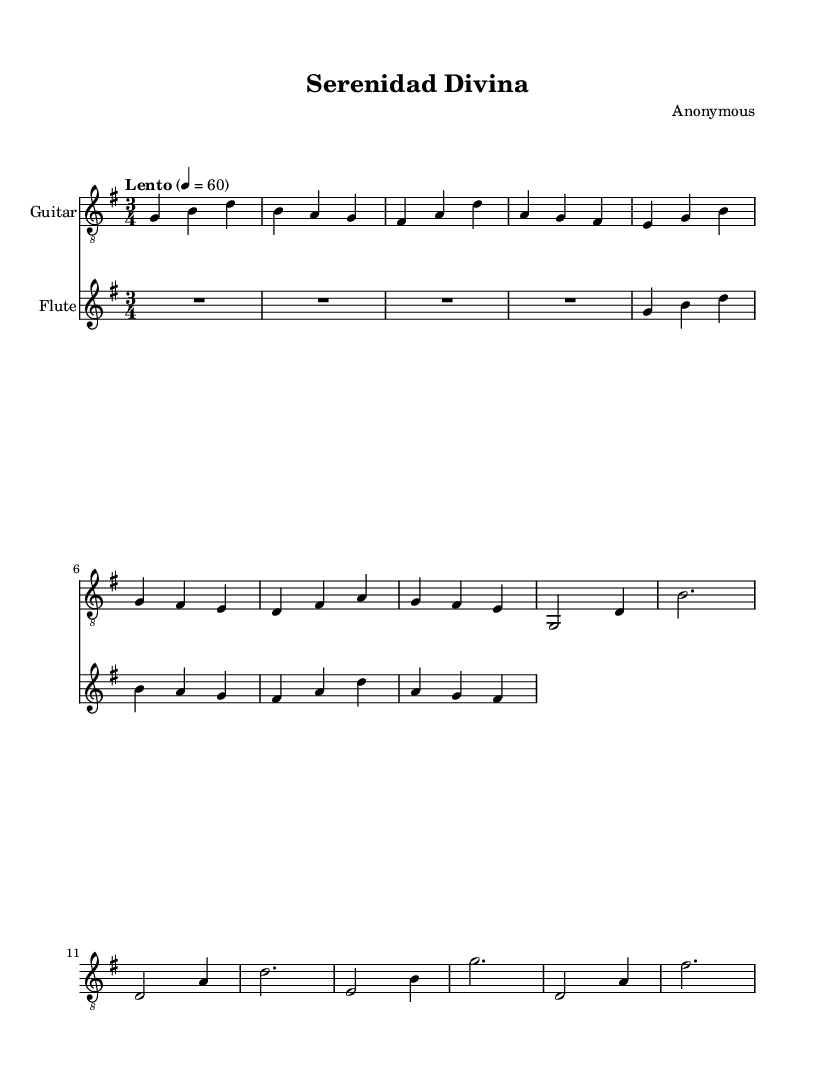What is the key signature of this music? The key signature appears at the beginning of the staff; it shows one sharp, indicating it's in G major.
Answer: G major What is the time signature of this music? The time signature is found at the beginning of the sheet music and is indicated as 3/4, meaning there are three beats per measure, and a quarter note receives one beat.
Answer: 3/4 What is the tempo marking of this piece? The tempo marking is indicated directly above the staff and states "Lento," which means the piece should be played slowly.
Answer: Lento How many measures are in the guitar part? By counting the distinct groups of notes separated by vertical lines (bar lines), we can see there are 12 measures in the guitar part.
Answer: 12 What instrument plays the melody? The melody is indicated on the staff above the guitar part, and it is shown as being played by the flute.
Answer: Flute In which mode is this piece primarily composed? This piece predominantly uses the major scale structure, which is defined as having a happy and uplifting sound, typical for many Latin instrumental pieces.
Answer: Major What is the dynamic level of the piece suggested by the score? The sheet music does not explicitly state dynamics, but the overall reflective nature of the piece, marked by "Lento," implies a soft and serene dynamic if interpreted by performers.
Answer: Soft 